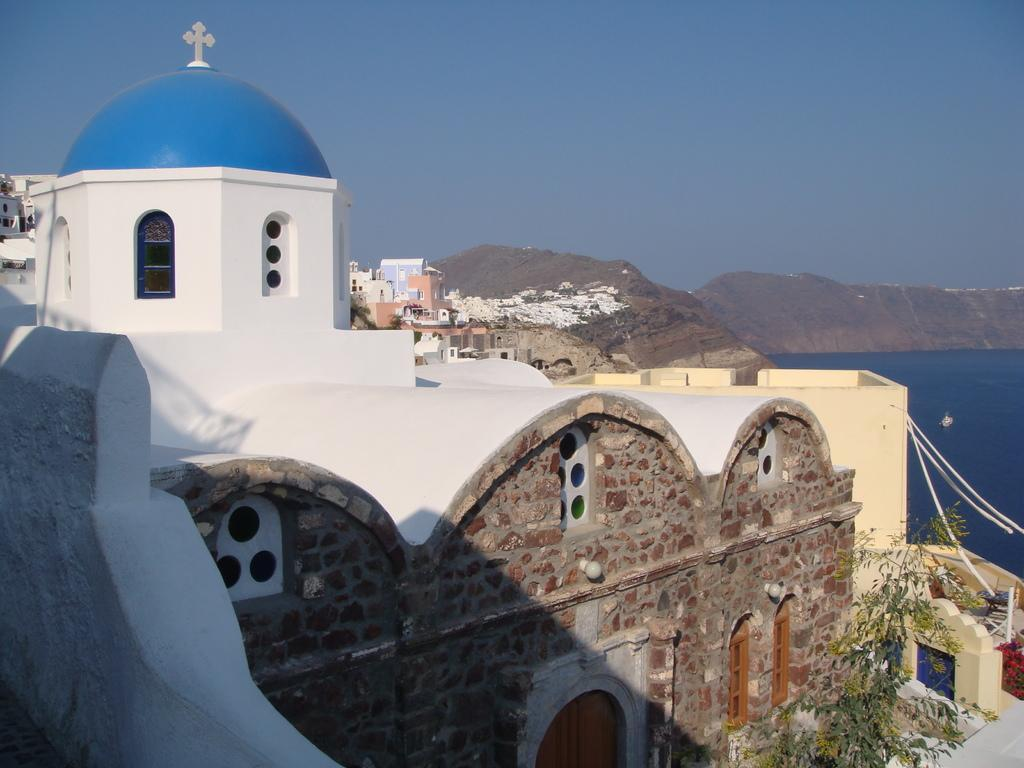What type of structures can be seen in the image? There are buildings in the image. What else is present in the image besides buildings? There are objects and plants visible in the image. What can be seen in the background of the image? Water, rocks, and the sky are visible in the background of the image. Can you tell me how many people are coughing in the image? There is no indication of people coughing in the image. What type of hand can be seen interacting with the objects in the image? There are no hands visible in the image; only buildings, objects, plants, water, rocks, and the sky are present. 